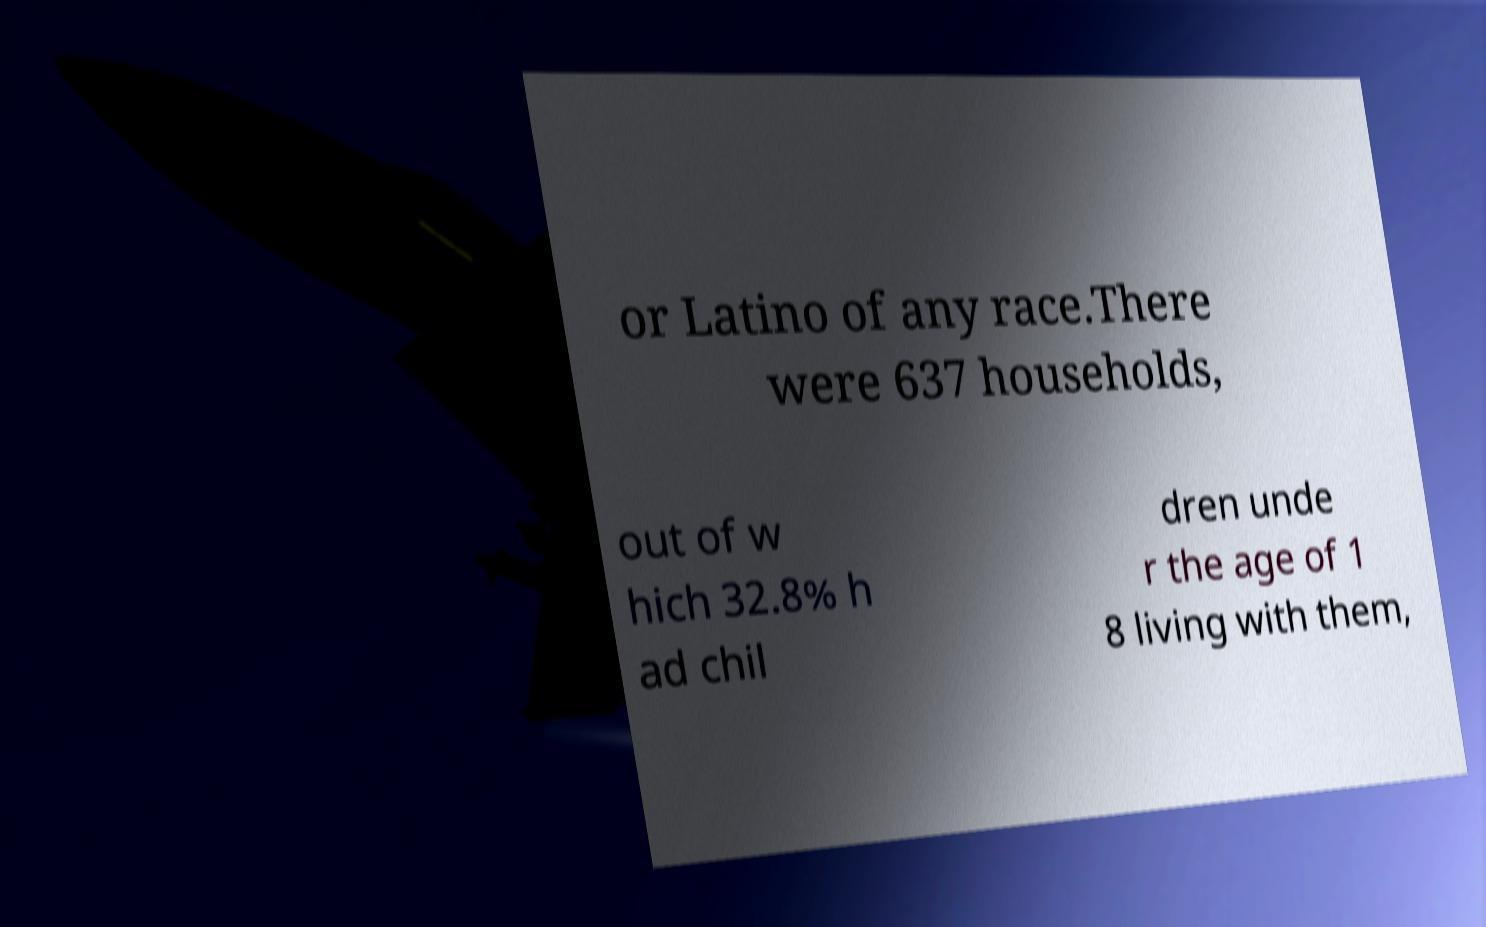Please read and relay the text visible in this image. What does it say? or Latino of any race.There were 637 households, out of w hich 32.8% h ad chil dren unde r the age of 1 8 living with them, 